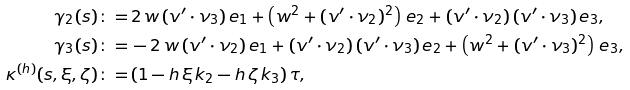Convert formula to latex. <formula><loc_0><loc_0><loc_500><loc_500>\gamma _ { 2 } ( s ) \colon = & \, 2 \, w \, ( v ^ { \prime } \cdot \nu _ { 3 } ) \, e _ { 1 } + \left ( w ^ { 2 } + ( v ^ { \prime } \cdot \nu _ { 2 } ) ^ { 2 } \right ) \, e _ { 2 } + ( v ^ { \prime } \cdot \nu _ { 2 } ) \, ( v ^ { \prime } \cdot \nu _ { 3 } ) \, e _ { 3 } , \\ \gamma _ { 3 } ( s ) \colon = & \, - 2 \, w \, ( v ^ { \prime } \cdot \nu _ { 2 } ) \, e _ { 1 } + ( v ^ { \prime } \cdot \nu _ { 2 } ) \, ( v ^ { \prime } \cdot \nu _ { 3 } ) \, e _ { 2 } + \left ( w ^ { 2 } + ( v ^ { \prime } \cdot \nu _ { 3 } ) ^ { 2 } \right ) \, e _ { 3 } , \\ \kappa ^ { ( h ) } ( s , \xi , \zeta ) \colon = & \, ( 1 - h \, \xi \, k _ { 2 } - h \, \zeta \, k _ { 3 } ) \, \tau ,</formula> 